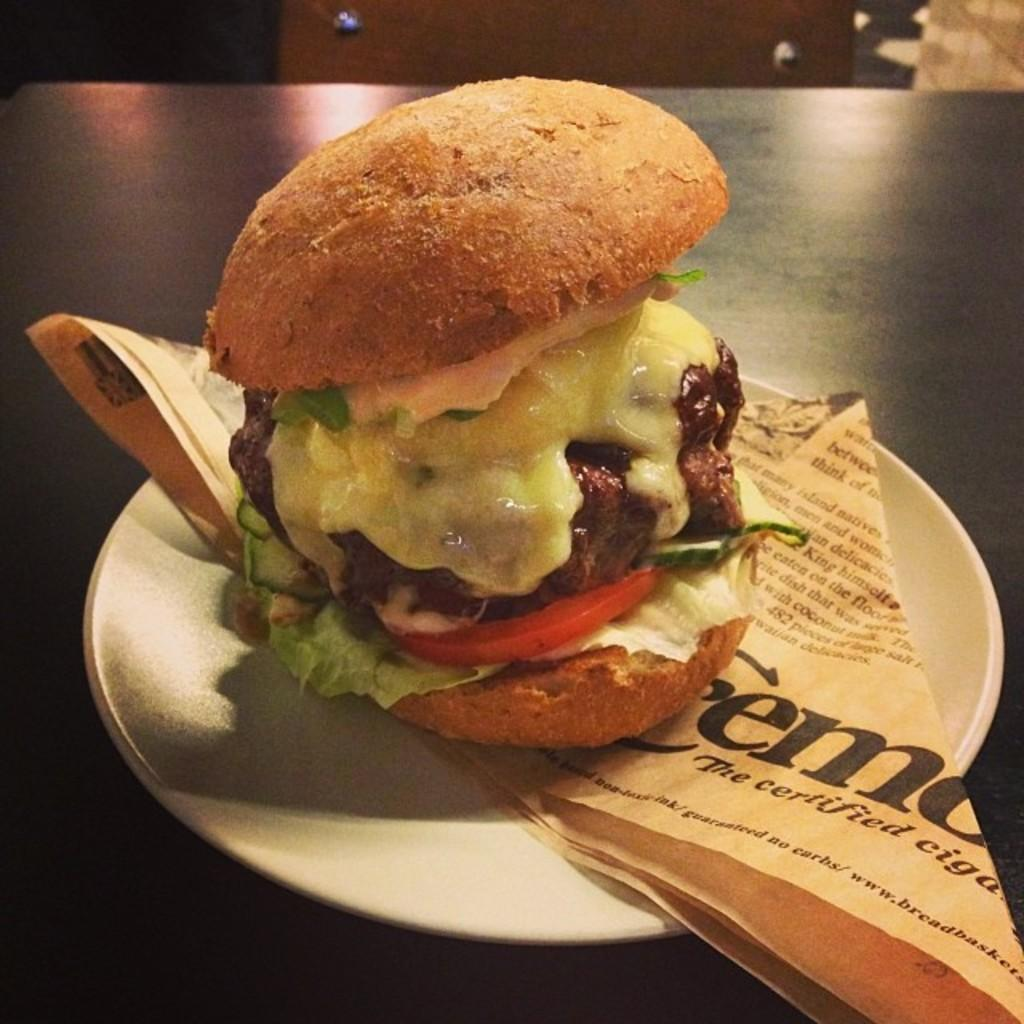What type of food is visible in the image? There is a burger in the image. How is the burger presented? The burger is served on a plate. What else is on the plate with the burger? There is a paper on the plate. Where is the plate with the burger located? The plate is on a table. Can you see the eye of the person who prepared the burger in the image? There is no person or eye visible in the image; it only shows a burger on a plate. 